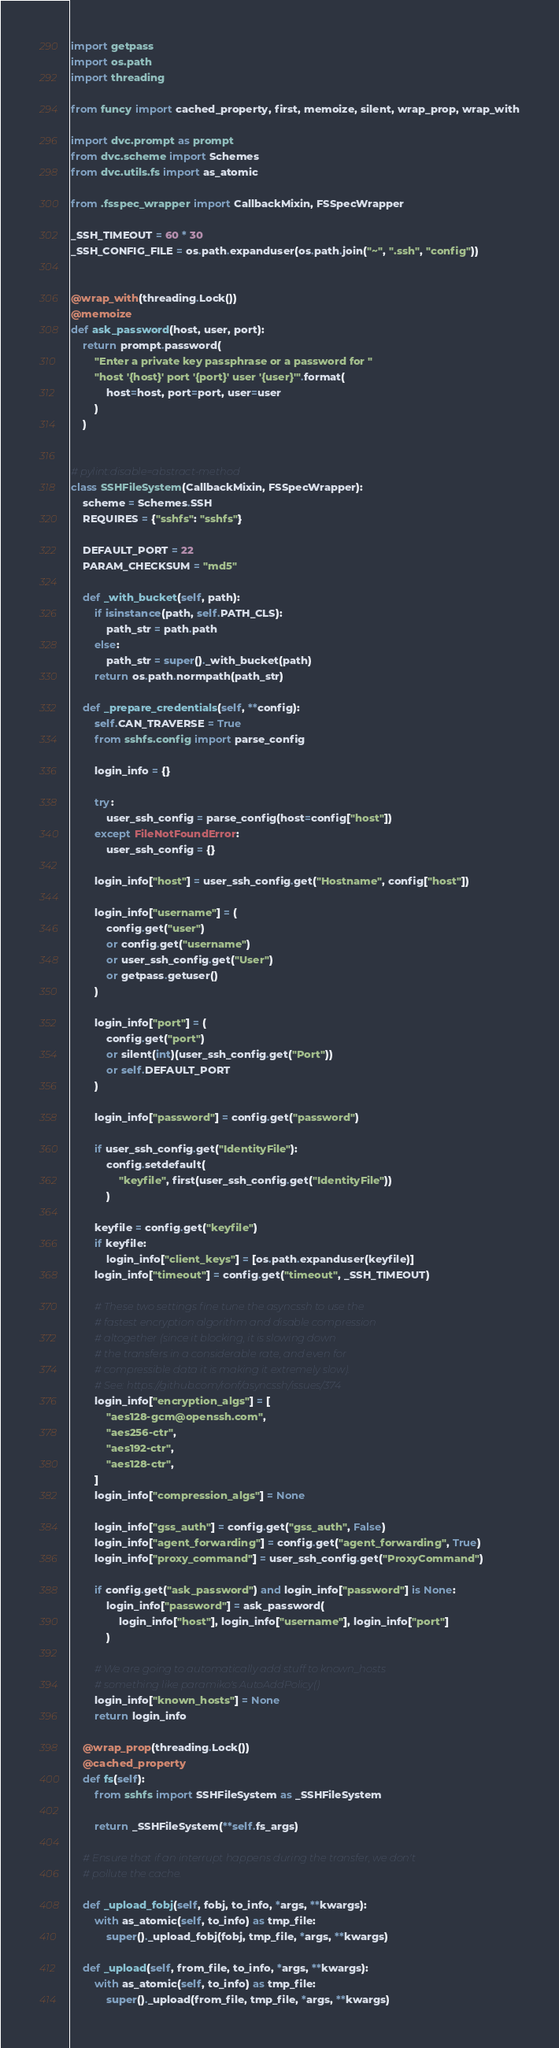<code> <loc_0><loc_0><loc_500><loc_500><_Python_>import getpass
import os.path
import threading

from funcy import cached_property, first, memoize, silent, wrap_prop, wrap_with

import dvc.prompt as prompt
from dvc.scheme import Schemes
from dvc.utils.fs import as_atomic

from .fsspec_wrapper import CallbackMixin, FSSpecWrapper

_SSH_TIMEOUT = 60 * 30
_SSH_CONFIG_FILE = os.path.expanduser(os.path.join("~", ".ssh", "config"))


@wrap_with(threading.Lock())
@memoize
def ask_password(host, user, port):
    return prompt.password(
        "Enter a private key passphrase or a password for "
        "host '{host}' port '{port}' user '{user}'".format(
            host=host, port=port, user=user
        )
    )


# pylint:disable=abstract-method
class SSHFileSystem(CallbackMixin, FSSpecWrapper):
    scheme = Schemes.SSH
    REQUIRES = {"sshfs": "sshfs"}

    DEFAULT_PORT = 22
    PARAM_CHECKSUM = "md5"

    def _with_bucket(self, path):
        if isinstance(path, self.PATH_CLS):
            path_str = path.path
        else:
            path_str = super()._with_bucket(path)
        return os.path.normpath(path_str)

    def _prepare_credentials(self, **config):
        self.CAN_TRAVERSE = True
        from sshfs.config import parse_config

        login_info = {}

        try:
            user_ssh_config = parse_config(host=config["host"])
        except FileNotFoundError:
            user_ssh_config = {}

        login_info["host"] = user_ssh_config.get("Hostname", config["host"])

        login_info["username"] = (
            config.get("user")
            or config.get("username")
            or user_ssh_config.get("User")
            or getpass.getuser()
        )

        login_info["port"] = (
            config.get("port")
            or silent(int)(user_ssh_config.get("Port"))
            or self.DEFAULT_PORT
        )

        login_info["password"] = config.get("password")

        if user_ssh_config.get("IdentityFile"):
            config.setdefault(
                "keyfile", first(user_ssh_config.get("IdentityFile"))
            )

        keyfile = config.get("keyfile")
        if keyfile:
            login_info["client_keys"] = [os.path.expanduser(keyfile)]
        login_info["timeout"] = config.get("timeout", _SSH_TIMEOUT)

        # These two settings fine tune the asyncssh to use the
        # fastest encryption algorithm and disable compression
        # altogether (since it blocking, it is slowing down
        # the transfers in a considerable rate, and even for
        # compressible data it is making it extremely slow).
        # See: https://github.com/ronf/asyncssh/issues/374
        login_info["encryption_algs"] = [
            "aes128-gcm@openssh.com",
            "aes256-ctr",
            "aes192-ctr",
            "aes128-ctr",
        ]
        login_info["compression_algs"] = None

        login_info["gss_auth"] = config.get("gss_auth", False)
        login_info["agent_forwarding"] = config.get("agent_forwarding", True)
        login_info["proxy_command"] = user_ssh_config.get("ProxyCommand")

        if config.get("ask_password") and login_info["password"] is None:
            login_info["password"] = ask_password(
                login_info["host"], login_info["username"], login_info["port"]
            )

        # We are going to automatically add stuff to known_hosts
        # something like paramiko's AutoAddPolicy()
        login_info["known_hosts"] = None
        return login_info

    @wrap_prop(threading.Lock())
    @cached_property
    def fs(self):
        from sshfs import SSHFileSystem as _SSHFileSystem

        return _SSHFileSystem(**self.fs_args)

    # Ensure that if an interrupt happens during the transfer, we don't
    # pollute the cache.

    def _upload_fobj(self, fobj, to_info, *args, **kwargs):
        with as_atomic(self, to_info) as tmp_file:
            super()._upload_fobj(fobj, tmp_file, *args, **kwargs)

    def _upload(self, from_file, to_info, *args, **kwargs):
        with as_atomic(self, to_info) as tmp_file:
            super()._upload(from_file, tmp_file, *args, **kwargs)
</code> 